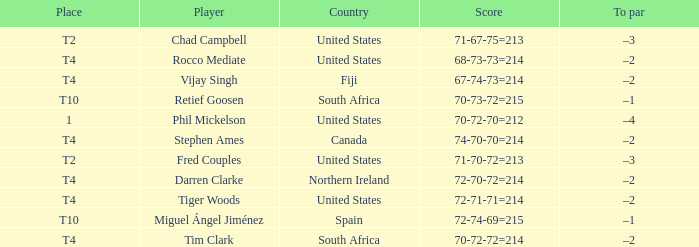What is Rocco Mediate's par? –2. 